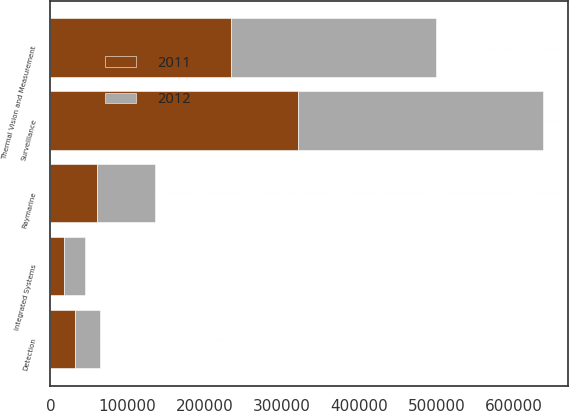Convert chart. <chart><loc_0><loc_0><loc_500><loc_500><stacked_bar_chart><ecel><fcel>Thermal Vision and Measurement<fcel>Raymarine<fcel>Surveillance<fcel>Detection<fcel>Integrated Systems<nl><fcel>2012<fcel>265197<fcel>74980<fcel>317944<fcel>31861<fcel>26559<nl><fcel>2011<fcel>233888<fcel>60093<fcel>320827<fcel>32447<fcel>17774<nl></chart> 